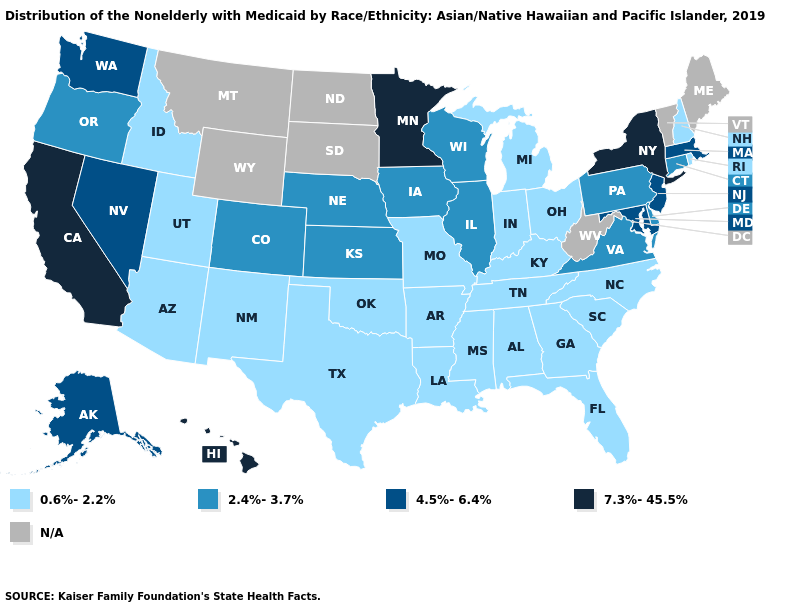Among the states that border Vermont , does New Hampshire have the highest value?
Keep it brief. No. Name the states that have a value in the range 2.4%-3.7%?
Give a very brief answer. Colorado, Connecticut, Delaware, Illinois, Iowa, Kansas, Nebraska, Oregon, Pennsylvania, Virginia, Wisconsin. Name the states that have a value in the range N/A?
Quick response, please. Maine, Montana, North Dakota, South Dakota, Vermont, West Virginia, Wyoming. Among the states that border Florida , which have the lowest value?
Short answer required. Alabama, Georgia. How many symbols are there in the legend?
Quick response, please. 5. Name the states that have a value in the range 7.3%-45.5%?
Write a very short answer. California, Hawaii, Minnesota, New York. Does the map have missing data?
Concise answer only. Yes. Name the states that have a value in the range 7.3%-45.5%?
Short answer required. California, Hawaii, Minnesota, New York. Does California have the highest value in the USA?
Write a very short answer. Yes. What is the value of Arizona?
Keep it brief. 0.6%-2.2%. Name the states that have a value in the range 4.5%-6.4%?
Short answer required. Alaska, Maryland, Massachusetts, Nevada, New Jersey, Washington. What is the value of Indiana?
Short answer required. 0.6%-2.2%. Does Colorado have the lowest value in the West?
Answer briefly. No. 